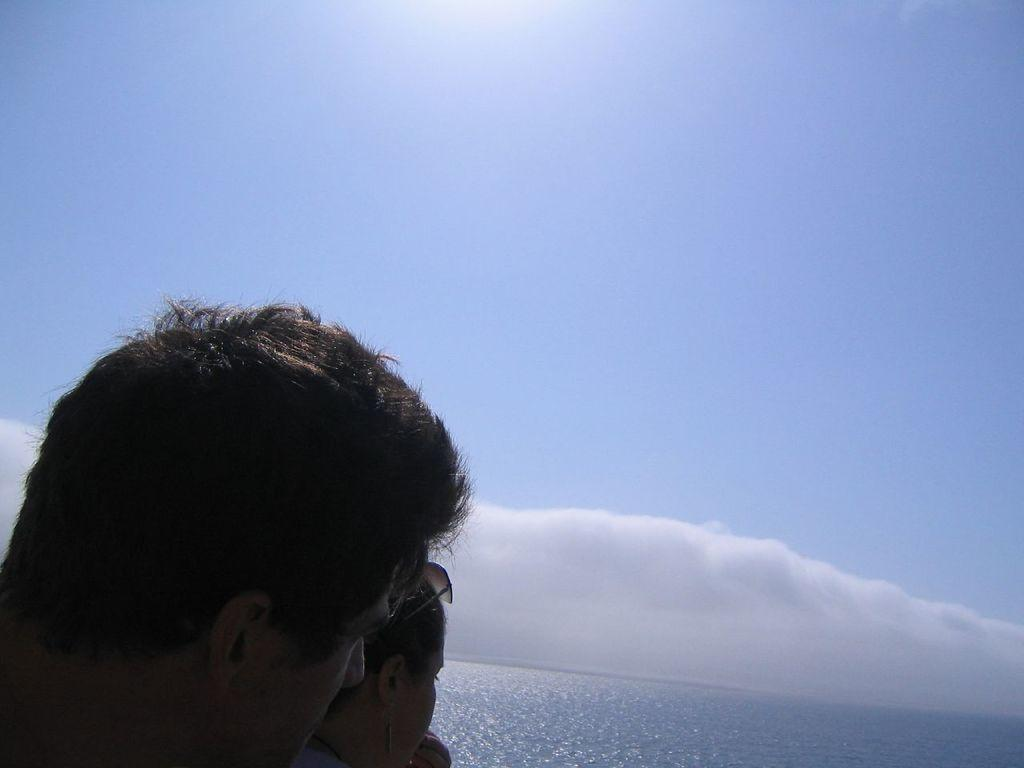What can be seen in the bottom left corner of the image? There are people standing in the bottom left corner of the image. What are the people doing in the image? The people are watching something. What is visible behind the people? There is water visible behind the people. What is the condition of the sky in the image? The sky is visible at the top of the image, and there are clouds present. Can you describe the celestial body visible in the sky? The sun is present in the sky. What type of stone is being used by the people in the image? There is no stone present in the image; the people are simply watching something. How does the society depicted in the image function? The image does not provide enough information to determine how the society functions. 